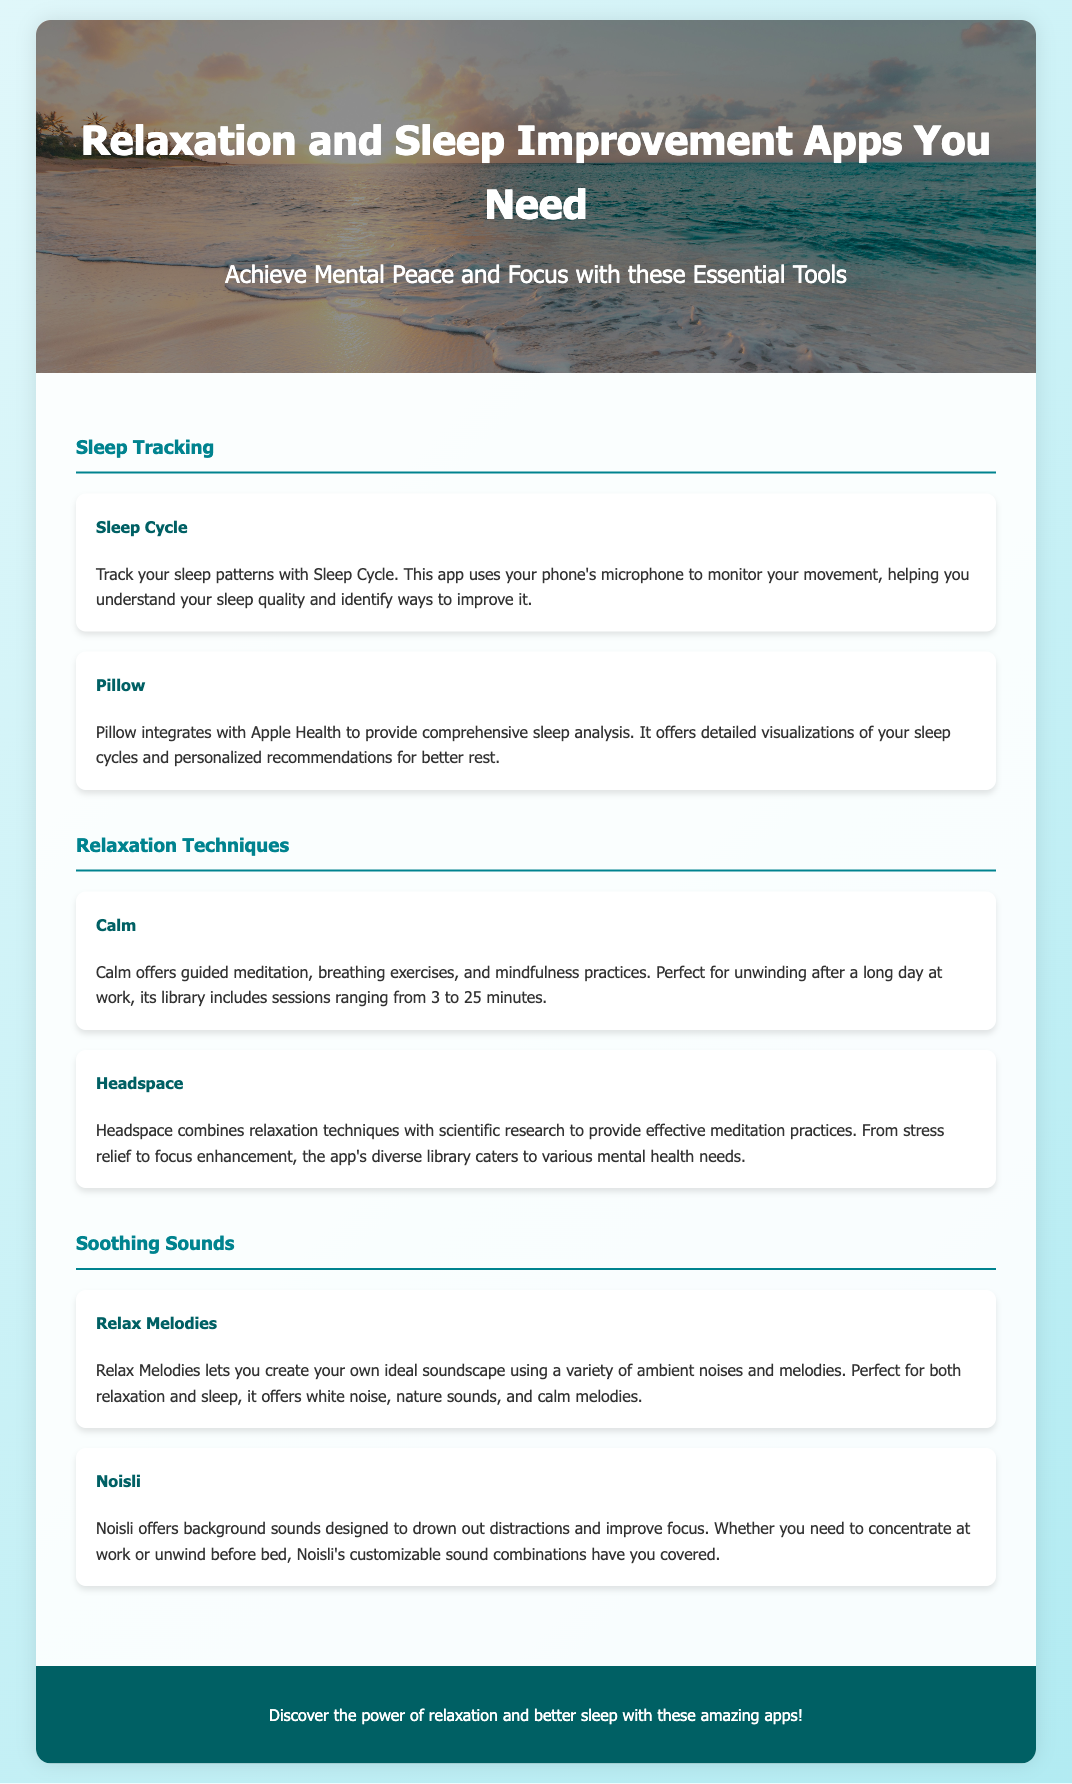what is the title of the document? The title of the document is prominently displayed at the top in a large font.
Answer: Relaxation and Sleep Improvement Apps You Need how many sleep tracking apps are mentioned? The document lists two specific apps under the sleep tracking section.
Answer: 2 what is the primary function of the app 'Calm'? The app 'Calm' is introduced with its main features described in a single sentence.
Answer: Guided meditation which app offers personalized recommendations for better rest? The document describes one app that integrates with Apple Health for comprehensive analysis and recommendations.
Answer: Pillow what color is used for the section headers? The color of the section headers is stated in the styling part of the document.
Answer: #00838f which app allows you to create your own soundscapes? The specific feature of creating soundscapes is associated with one app mentioned in the soothing sounds section.
Answer: Relax Melodies how long is the shortest session available on Calm? The document mentions the range of session lengths available within the app.
Answer: 3 minutes what is the primary target audience for the app 'Headspace'? The document indicates the app's purpose related to mental health needs.
Answer: Various mental health needs which section includes 'Noisli'? The document categorizes apps into specific sections, and one app is located under the soothing sounds section.
Answer: Soothing Sounds 